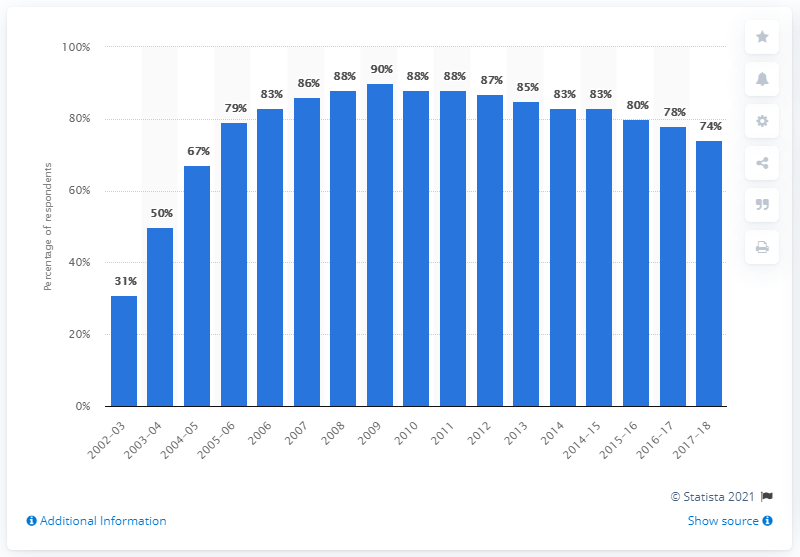Outline some significant characteristics in this image. In 2018, it was reported that 74% of households owned a DVD player. 